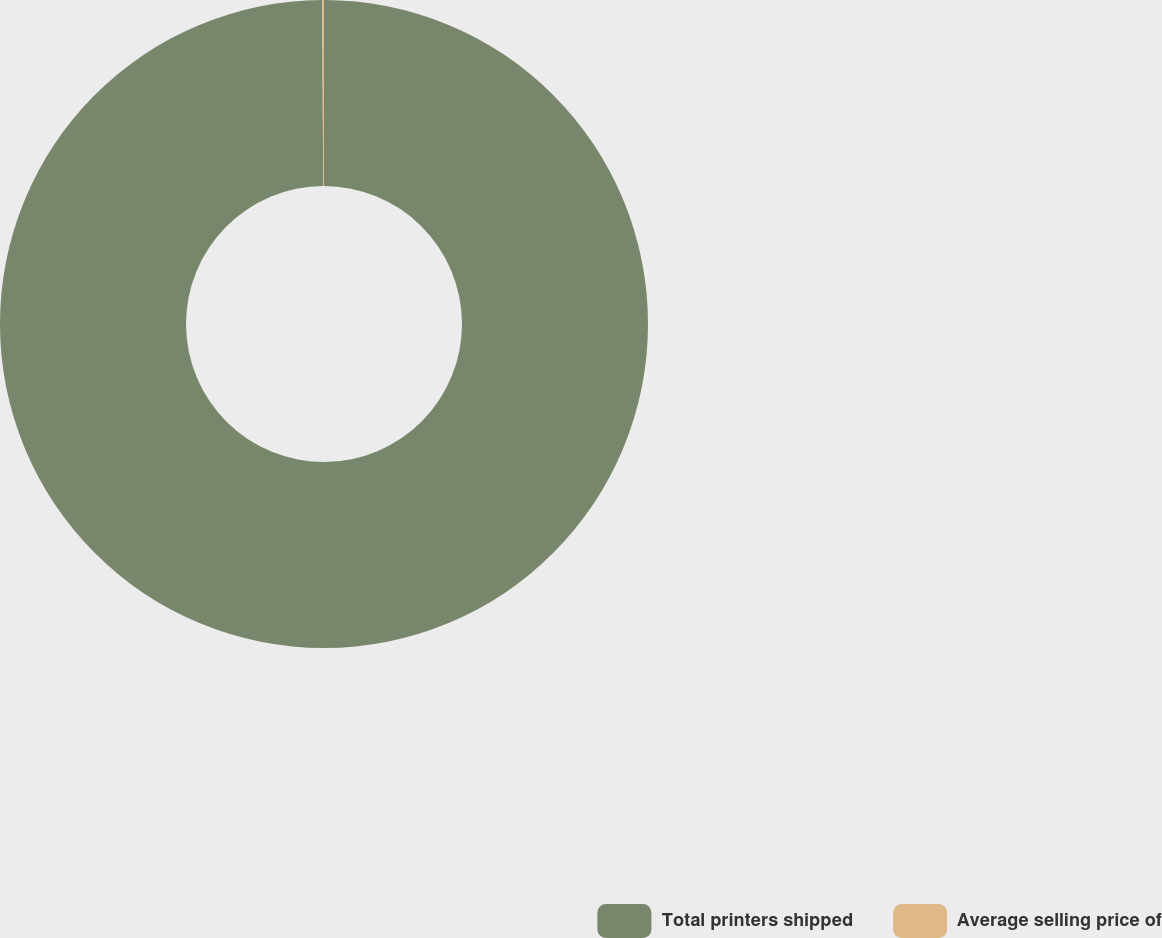Convert chart to OTSL. <chart><loc_0><loc_0><loc_500><loc_500><pie_chart><fcel>Total printers shipped<fcel>Average selling price of<nl><fcel>99.91%<fcel>0.09%<nl></chart> 